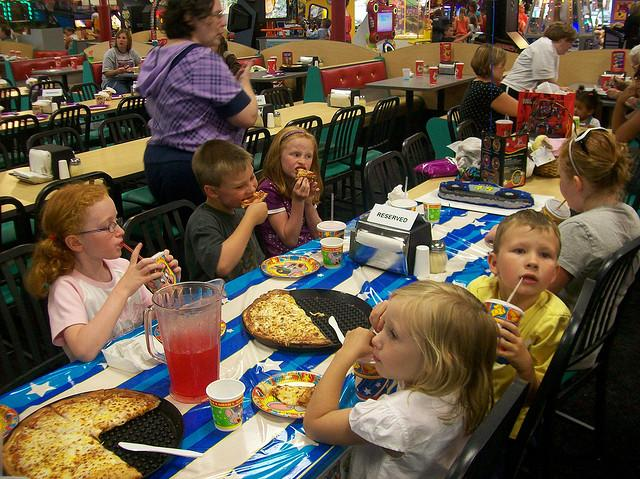What is a likely occasion for all the kids getting together? birthday party 